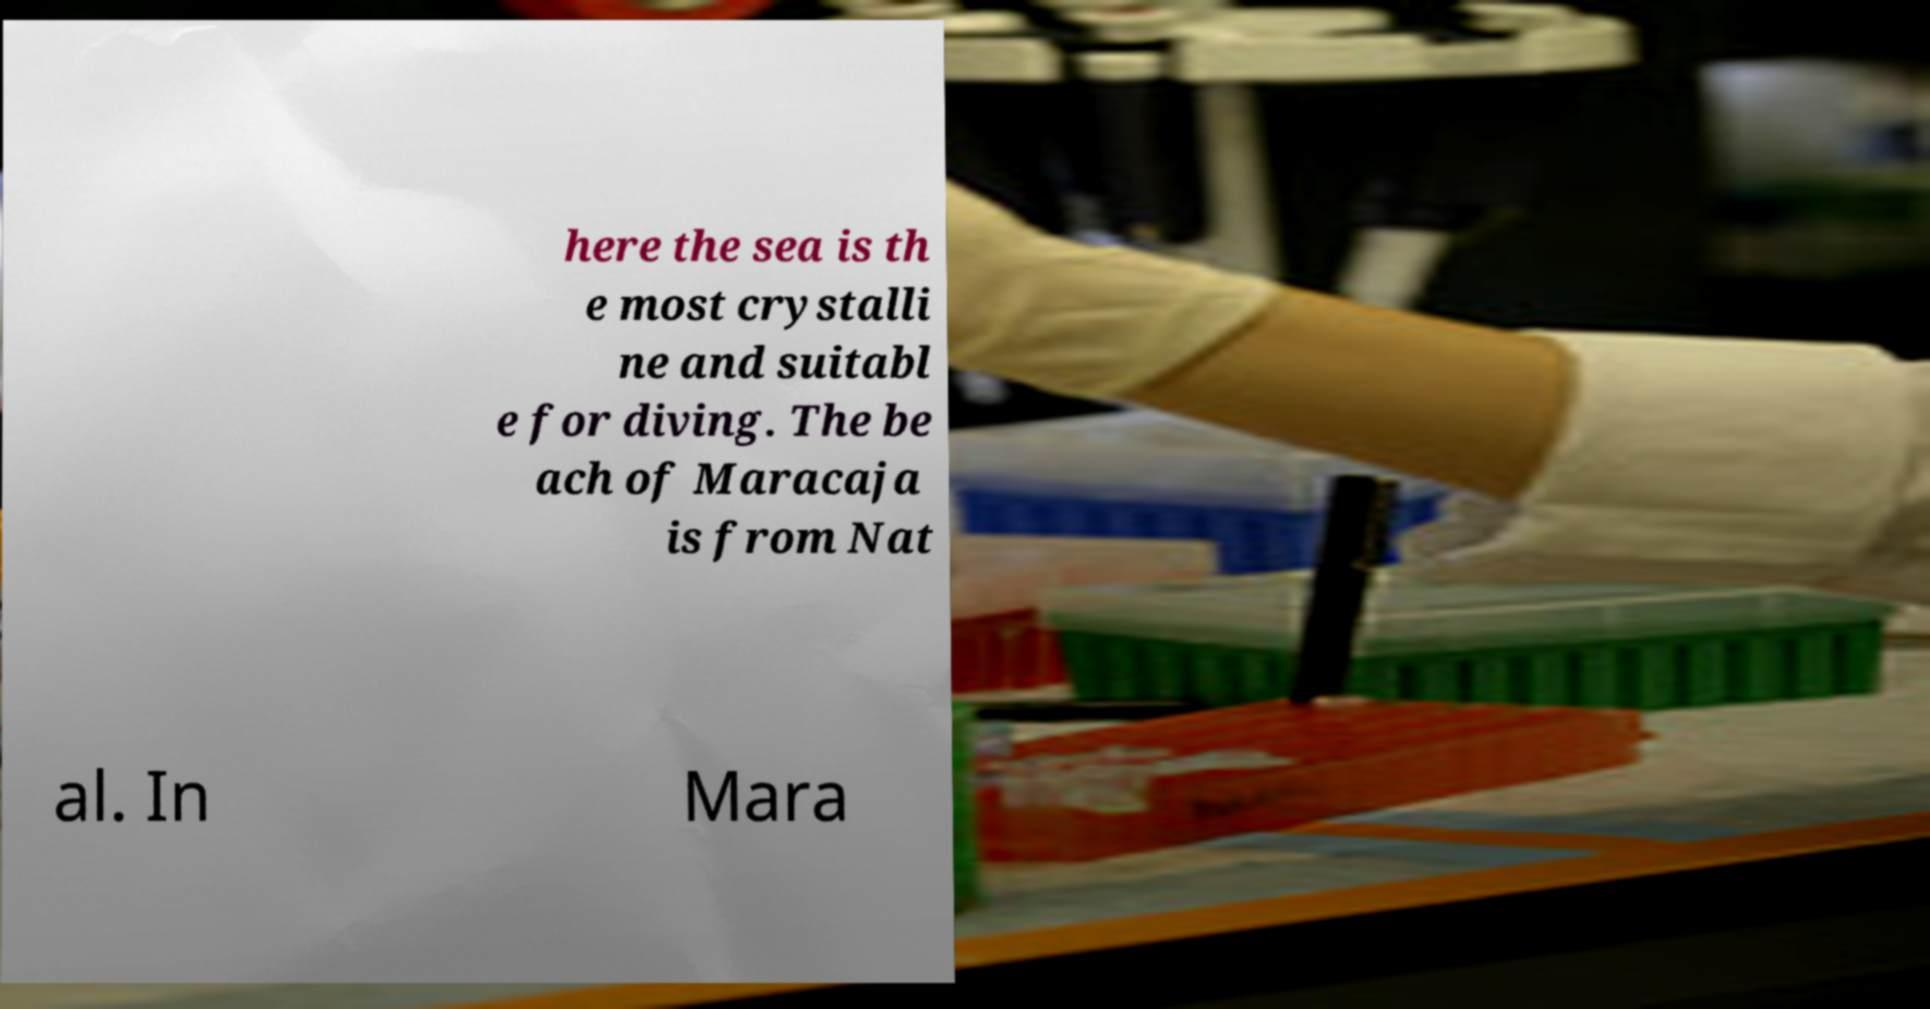Please read and relay the text visible in this image. What does it say? here the sea is th e most crystalli ne and suitabl e for diving. The be ach of Maracaja is from Nat al. In Mara 